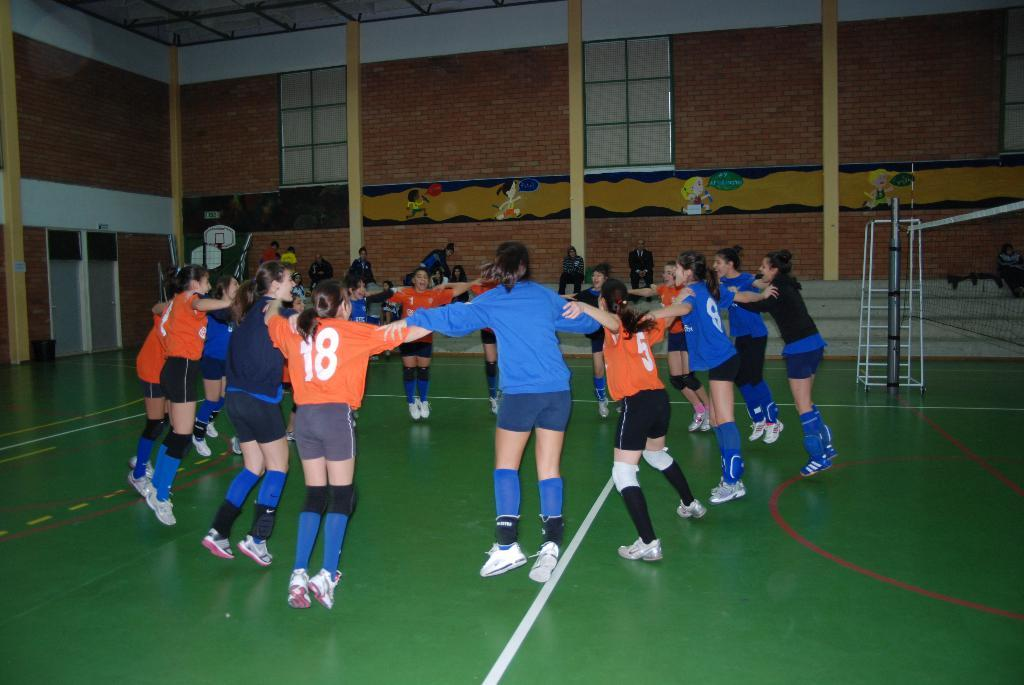<image>
Describe the image concisely. Number 18 joins in the celebration with the other athletes. 